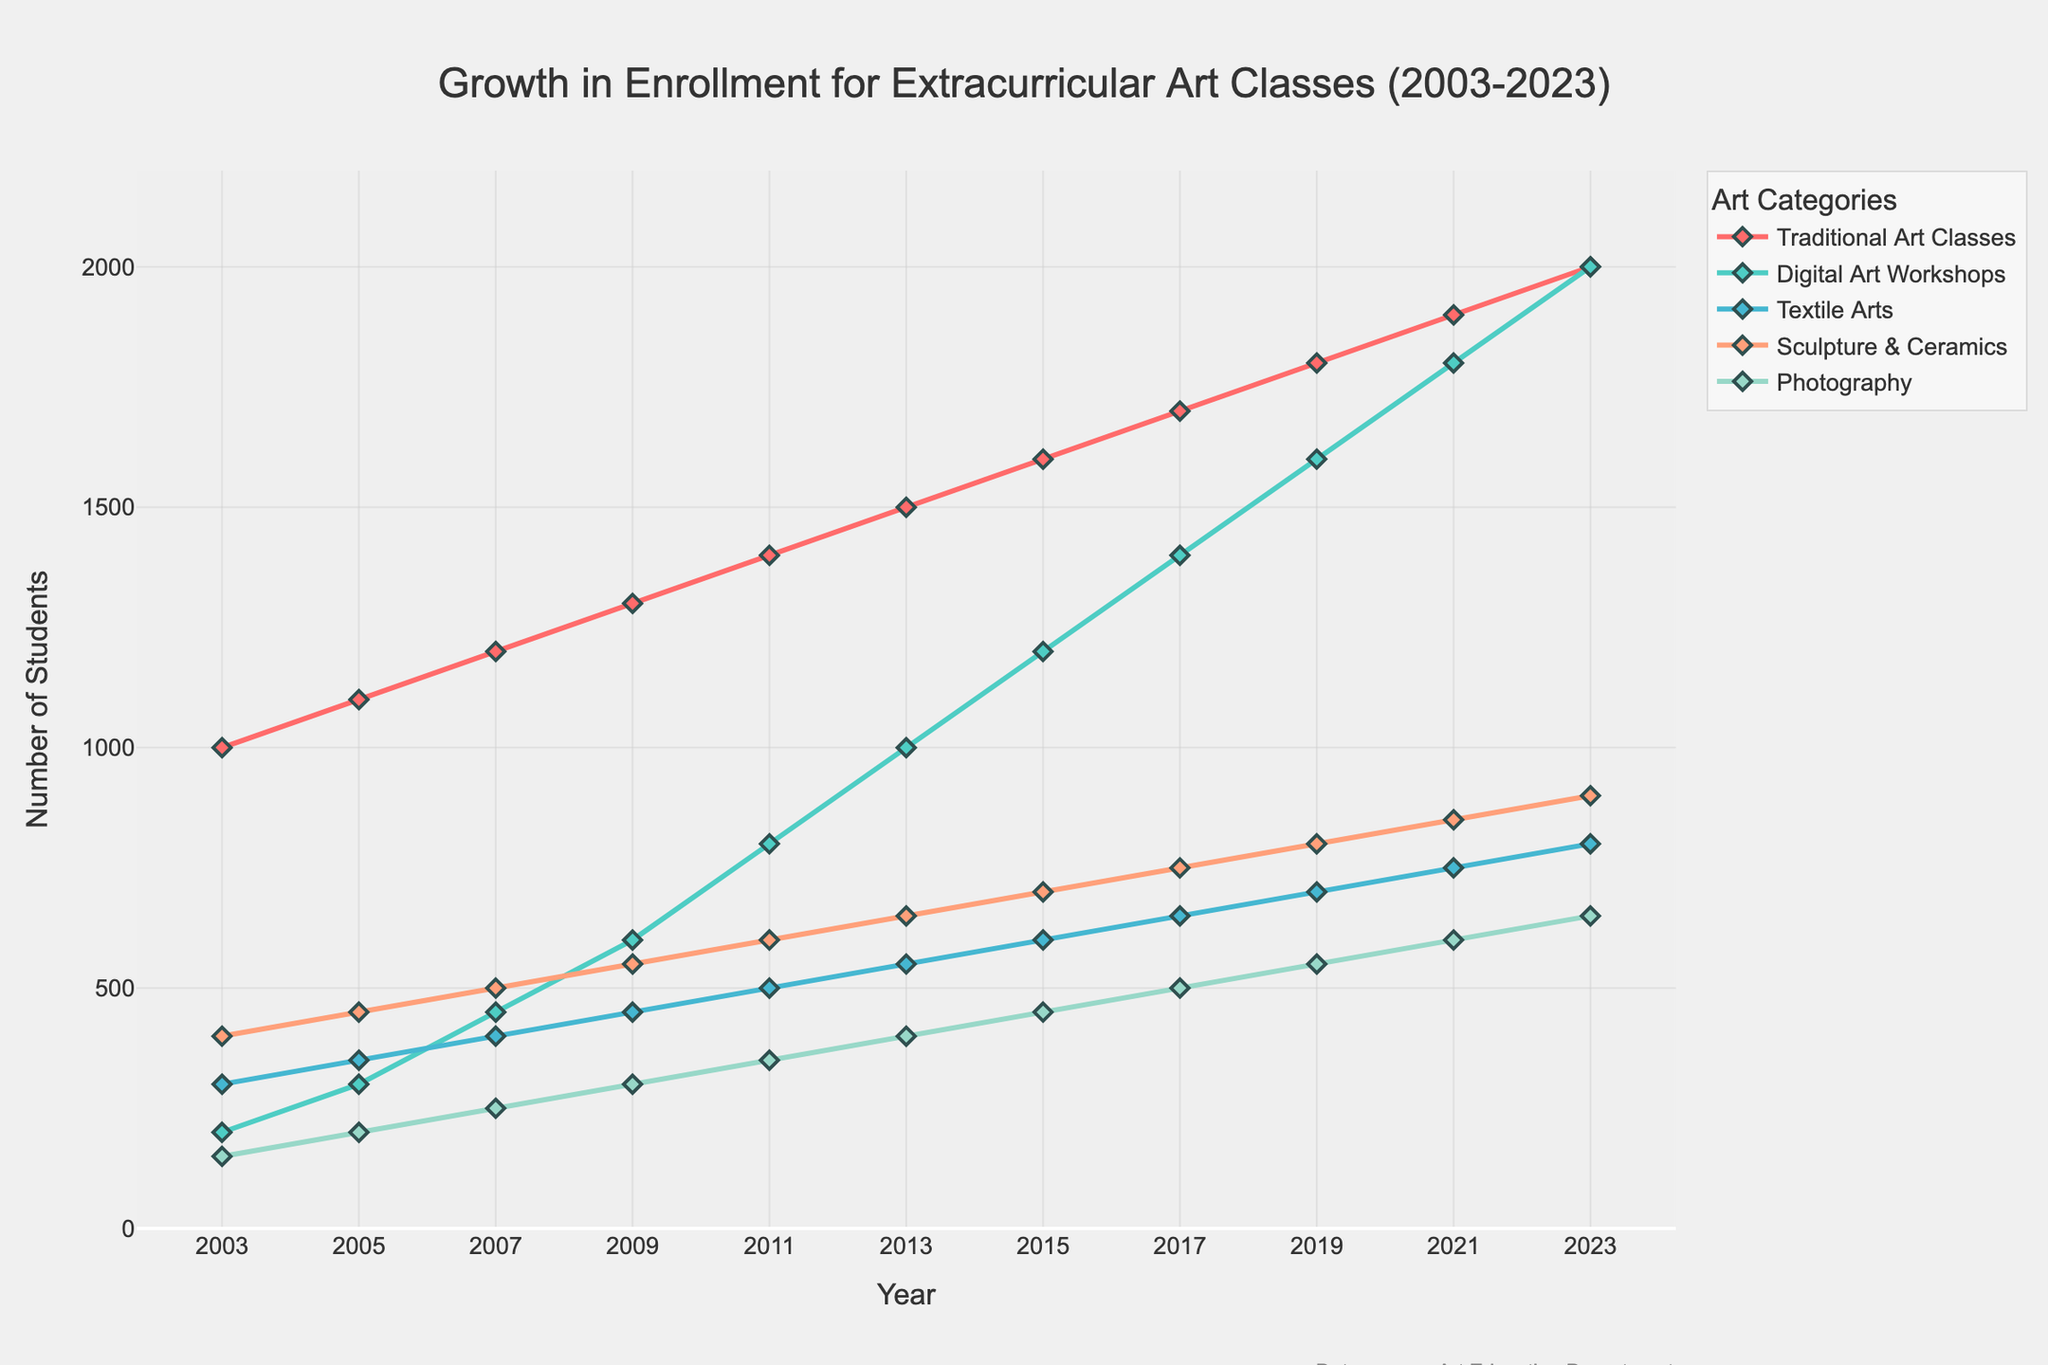What is the overall trend for enrollment in Traditional Art Classes from 2003 to 2023? The enrollment for Traditional Art Classes shows a consistent upward trend from 2003 to 2023, starting at 1000 students in 2003 and reaching 2000 students in 2023.
Answer: Upward trend Which category had the highest enrollment in 2023? In 2023, the Traditional Art Classes had the highest enrollment with 2000 students.
Answer: Traditional Art Classes What is the difference in enrollment between Photography and Sculpture & Ceramics in 2023? In 2023, the enrollment for Photography was 650 and for Sculpture & Ceramics was 900. The difference is 900 - 650 = 250.
Answer: 250 How has the enrollment in Digital Art Workshops changed from 2003 to 2023? The enrollment in Digital Art Workshops increased from 200 students in 2003 to 2000 students in 2023, showing significant growth.
Answer: Increased significantly What are the three art categories that showed continuous growth throughout the years? Traditional Art Classes, Digital Art Workshops, and Textile Arts showed continuous growth from 2003 to 2023.
Answer: Traditional Art Classes, Digital Art Workshops, Textile Arts Which year saw the largest increase in enrollment for Textile Arts? From 2011 to 2013, Textile Arts enrollment increased from 500 to 550, the largest increase observed. The increment is 550 - 500 = 50.
Answer: 2011-2013 How much did the enrollment for Sculpture & Ceramics increase from 2003 to 2023? Enrollment for Sculpture & Ceramics increased from 400 in 2003 to 900 in 2023. The increase is 900 - 400 = 500.
Answer: 500 Which category had the smallest growth in enrollment over the 20-year period? Photography had the smallest growth, from 150 students in 2003 to 650 students in 2023; an increase of 500.
Answer: Photography 